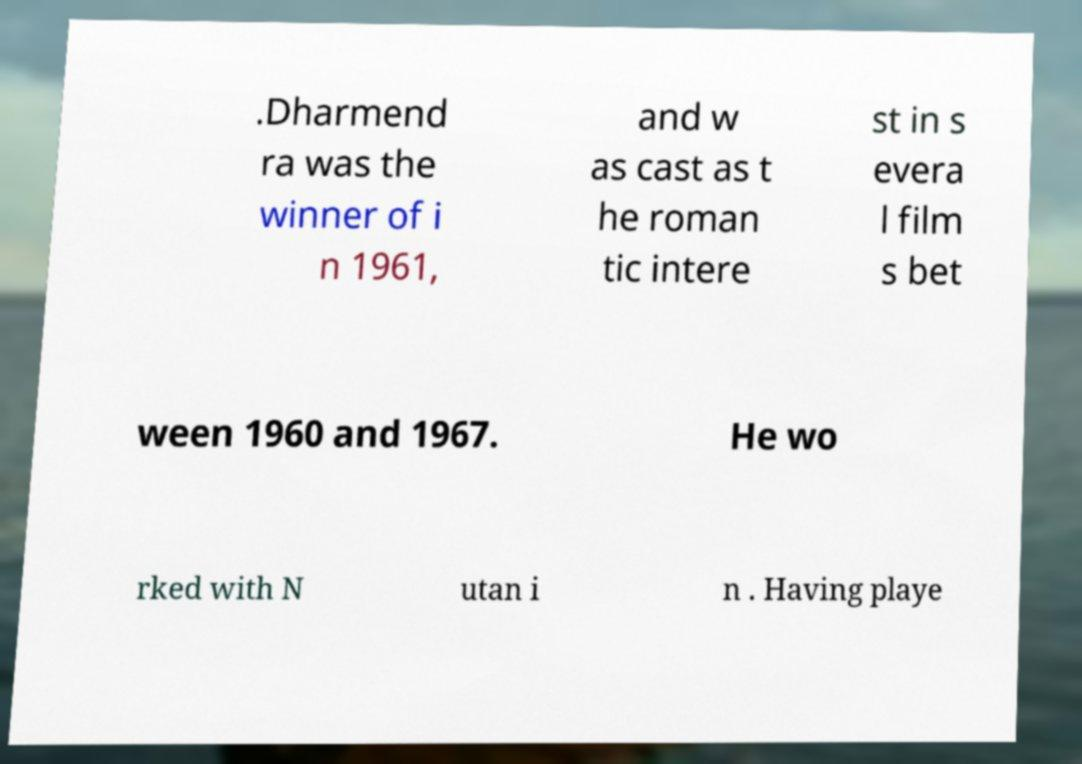Please read and relay the text visible in this image. What does it say? .Dharmend ra was the winner of i n 1961, and w as cast as t he roman tic intere st in s evera l film s bet ween 1960 and 1967. He wo rked with N utan i n . Having playe 